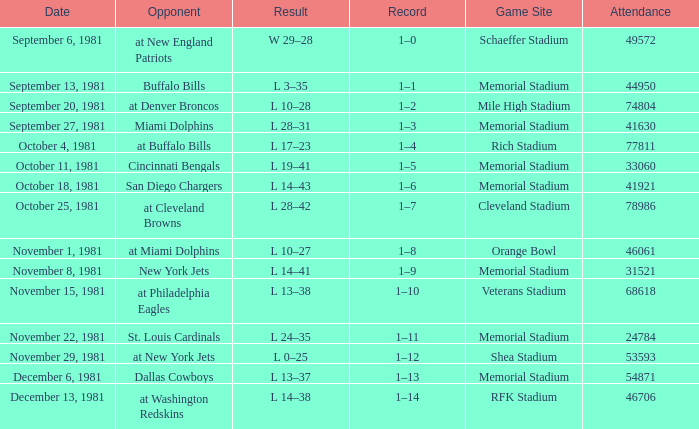In which week does the attendance reach 74,804? 3.0. 